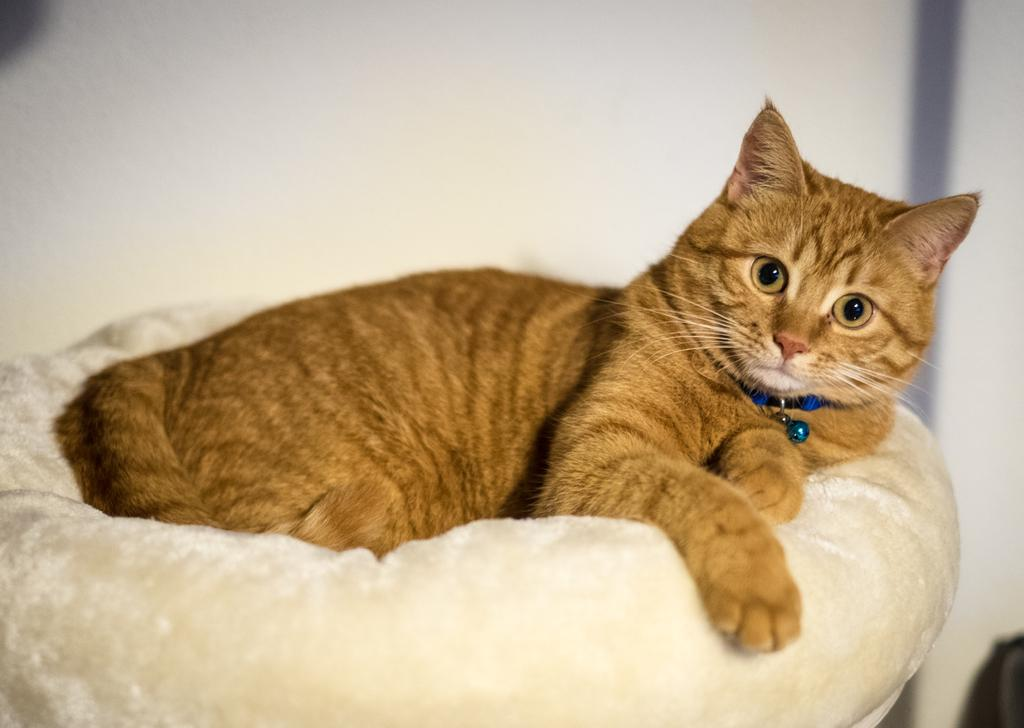What type of animal is present in the image? There is a cat in the image. Where is the cat sitting? The cat is sitting on a white color object. What is the cat wearing? The cat is wearing some object. What can be seen in the background of the image? There is a white color wall in the background of the image. What type of insurance policy is the cat holding in the image? There is no insurance policy present in the image; it features a cat sitting on a white color object and wearing some object. Can you see any signs of a bomb in the image? There is no indication of a bomb or any related objects in the image. 